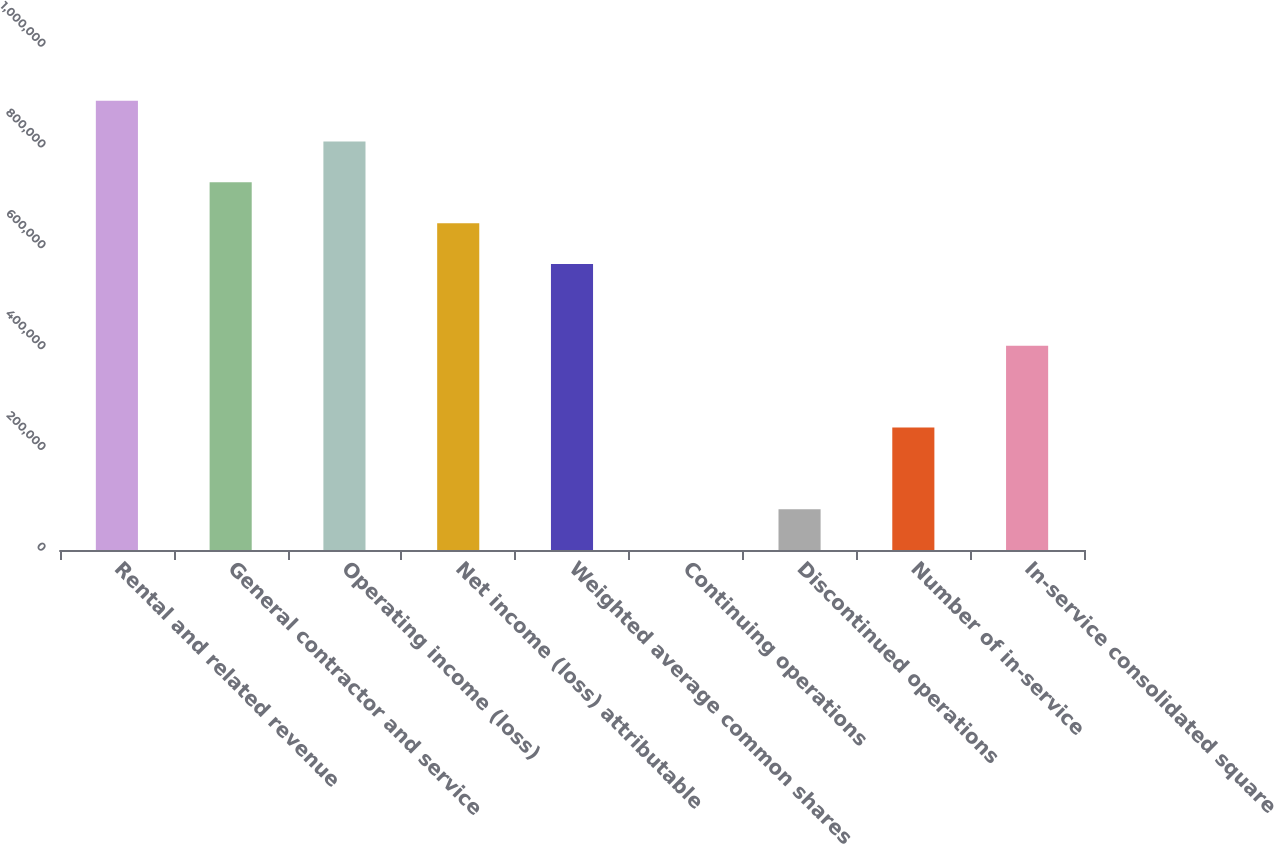Convert chart to OTSL. <chart><loc_0><loc_0><loc_500><loc_500><bar_chart><fcel>Rental and related revenue<fcel>General contractor and service<fcel>Operating income (loss)<fcel>Net income (loss) attributable<fcel>Weighted average common shares<fcel>Continuing operations<fcel>Discontinued operations<fcel>Number of in-service<fcel>In-service consolidated square<nl><fcel>891602<fcel>729492<fcel>810547<fcel>648438<fcel>567383<fcel>0.6<fcel>81055.2<fcel>243165<fcel>405274<nl></chart> 